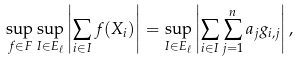<formula> <loc_0><loc_0><loc_500><loc_500>\sup _ { f \in F } \sup _ { I \in E _ { \ell } } \left | \sum _ { i \in I } f ( X _ { i } ) \right | = \sup _ { I \in E _ { \ell } } \left | \sum _ { i \in I } \sum _ { j = 1 } ^ { n } a _ { j } g _ { i , j } \right | ,</formula> 